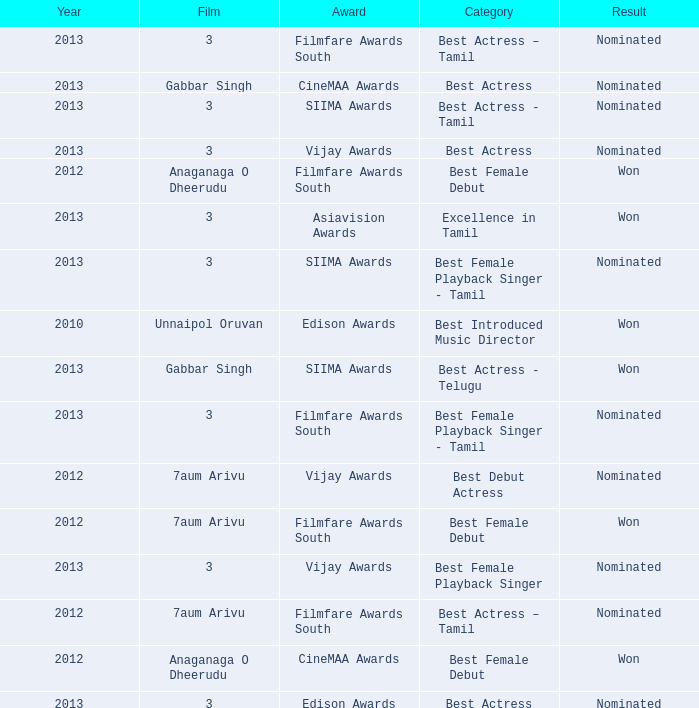What was the award for the excellence in tamil category? Asiavision Awards. 